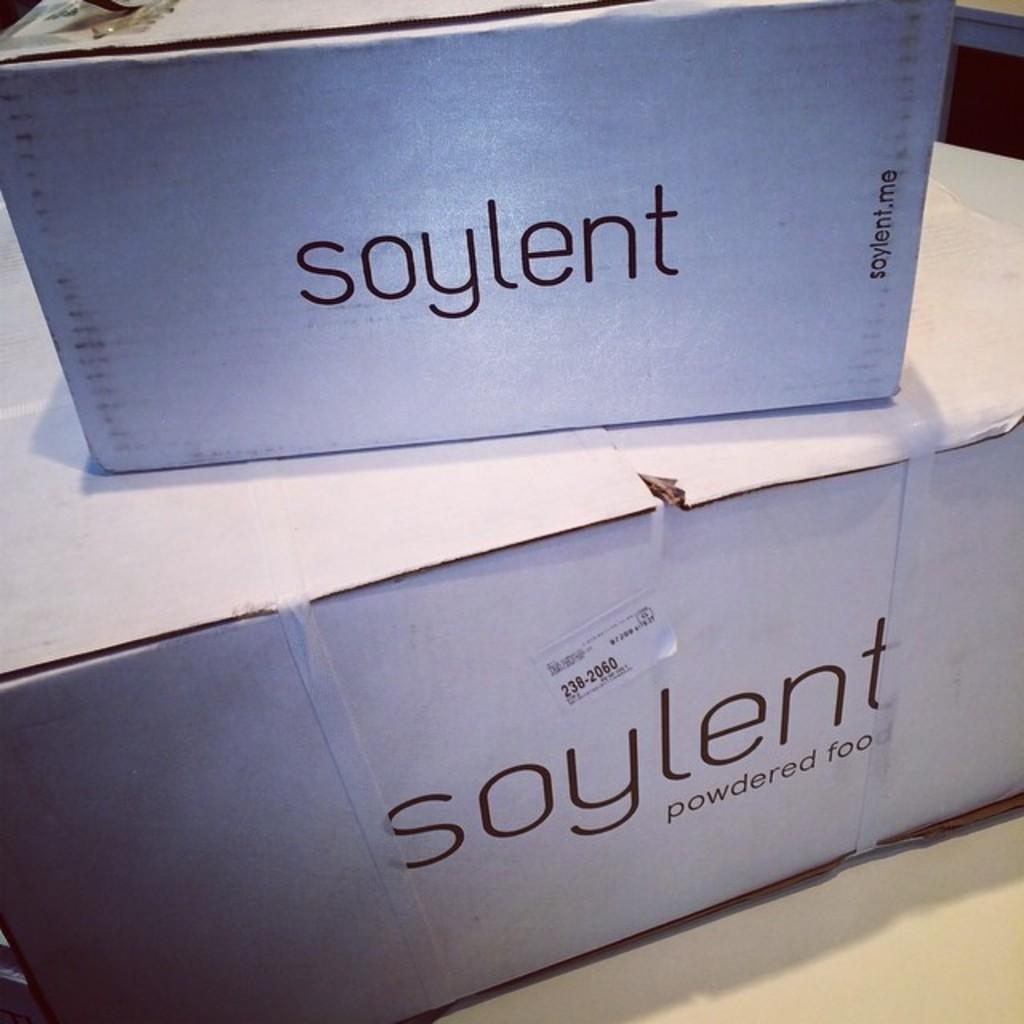What is inside the box?
Your answer should be compact. Powdered food. What is the seven-digit number above the brand name on the sticker?
Offer a very short reply. 238-2060. 